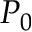<formula> <loc_0><loc_0><loc_500><loc_500>P _ { 0 }</formula> 